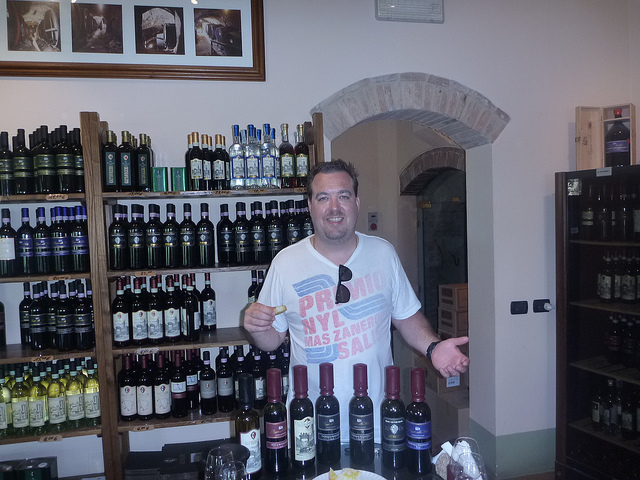How many bottles are in front of the man? 7 